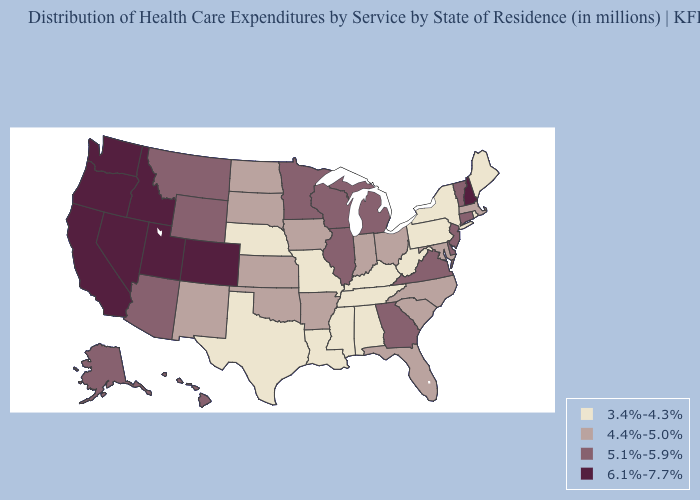What is the value of Kansas?
Be succinct. 4.4%-5.0%. What is the lowest value in the West?
Answer briefly. 4.4%-5.0%. What is the value of Illinois?
Give a very brief answer. 5.1%-5.9%. What is the value of Indiana?
Write a very short answer. 4.4%-5.0%. Name the states that have a value in the range 3.4%-4.3%?
Quick response, please. Alabama, Kentucky, Louisiana, Maine, Mississippi, Missouri, Nebraska, New York, Pennsylvania, Rhode Island, Tennessee, Texas, West Virginia. Does Mississippi have the same value as New York?
Write a very short answer. Yes. Which states hav the highest value in the South?
Short answer required. Delaware, Georgia, Virginia. What is the highest value in the South ?
Quick response, please. 5.1%-5.9%. Name the states that have a value in the range 3.4%-4.3%?
Concise answer only. Alabama, Kentucky, Louisiana, Maine, Mississippi, Missouri, Nebraska, New York, Pennsylvania, Rhode Island, Tennessee, Texas, West Virginia. What is the highest value in states that border Idaho?
Answer briefly. 6.1%-7.7%. Name the states that have a value in the range 5.1%-5.9%?
Keep it brief. Alaska, Arizona, Connecticut, Delaware, Georgia, Hawaii, Illinois, Michigan, Minnesota, Montana, New Jersey, Vermont, Virginia, Wisconsin, Wyoming. Among the states that border Nebraska , which have the highest value?
Concise answer only. Colorado. What is the value of California?
Answer briefly. 6.1%-7.7%. What is the lowest value in the MidWest?
Quick response, please. 3.4%-4.3%. Does Virginia have the highest value in the USA?
Concise answer only. No. 